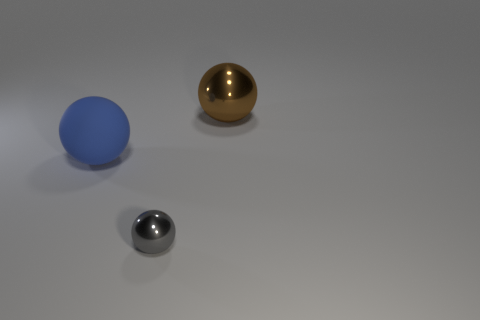Add 3 metal objects. How many objects exist? 6 Subtract all gray metallic objects. Subtract all big blue rubber objects. How many objects are left? 1 Add 3 rubber balls. How many rubber balls are left? 4 Add 3 large gray metal cylinders. How many large gray metal cylinders exist? 3 Subtract 1 brown balls. How many objects are left? 2 